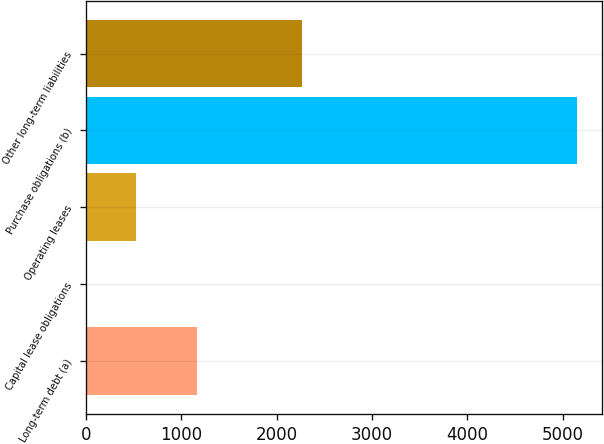Convert chart. <chart><loc_0><loc_0><loc_500><loc_500><bar_chart><fcel>Long-term debt (a)<fcel>Capital lease obligations<fcel>Operating leases<fcel>Purchase obligations (b)<fcel>Other long-term liabilities<nl><fcel>1167<fcel>4<fcel>518.9<fcel>5153<fcel>2267<nl></chart> 